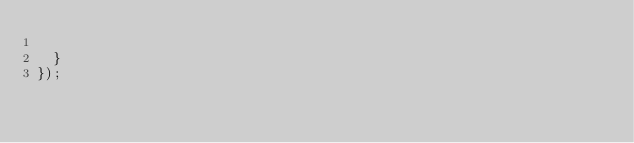Convert code to text. <code><loc_0><loc_0><loc_500><loc_500><_JavaScript_>
	}
});
</code> 